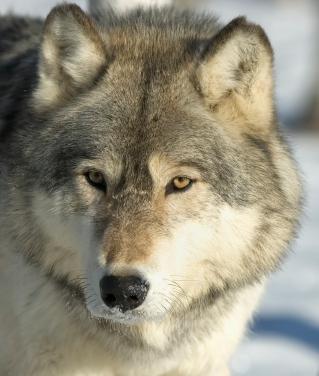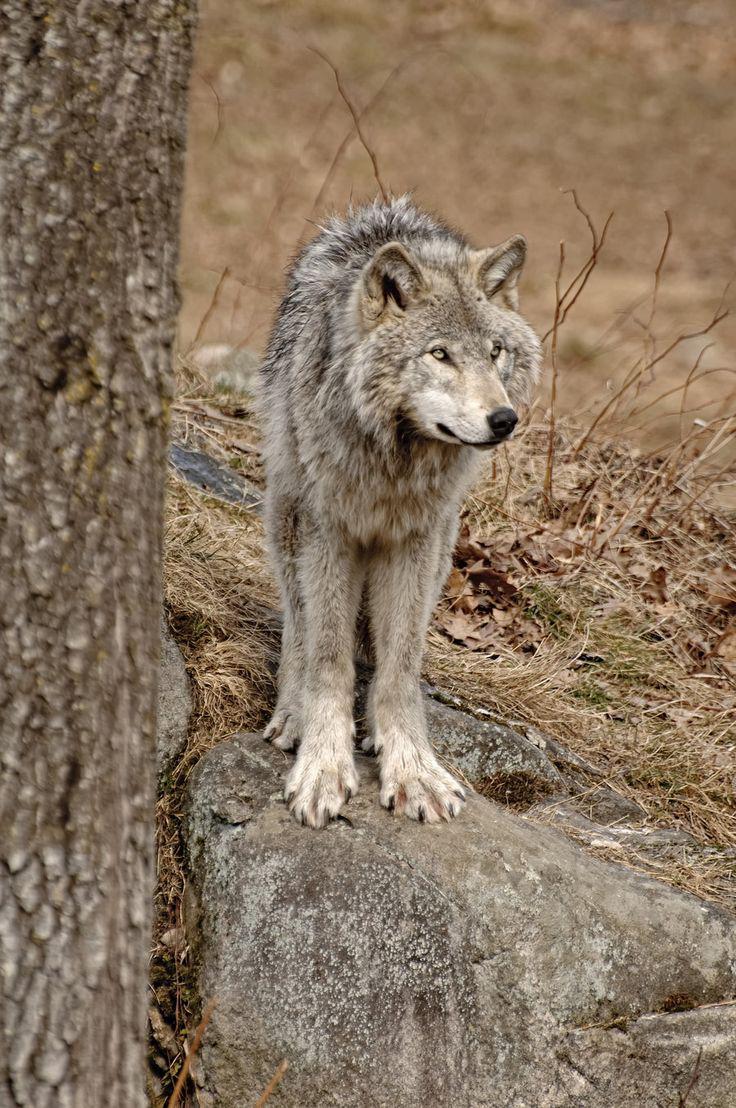The first image is the image on the left, the second image is the image on the right. Evaluate the accuracy of this statement regarding the images: "Only the head of the animal is visible in the image on the left.". Is it true? Answer yes or no. Yes. 